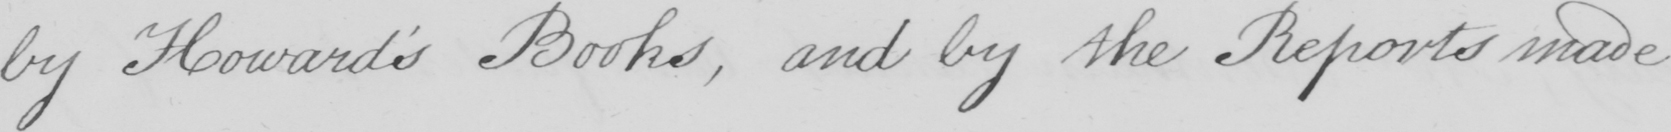Please provide the text content of this handwritten line. by Howard ' s Books , and by the Reports made 